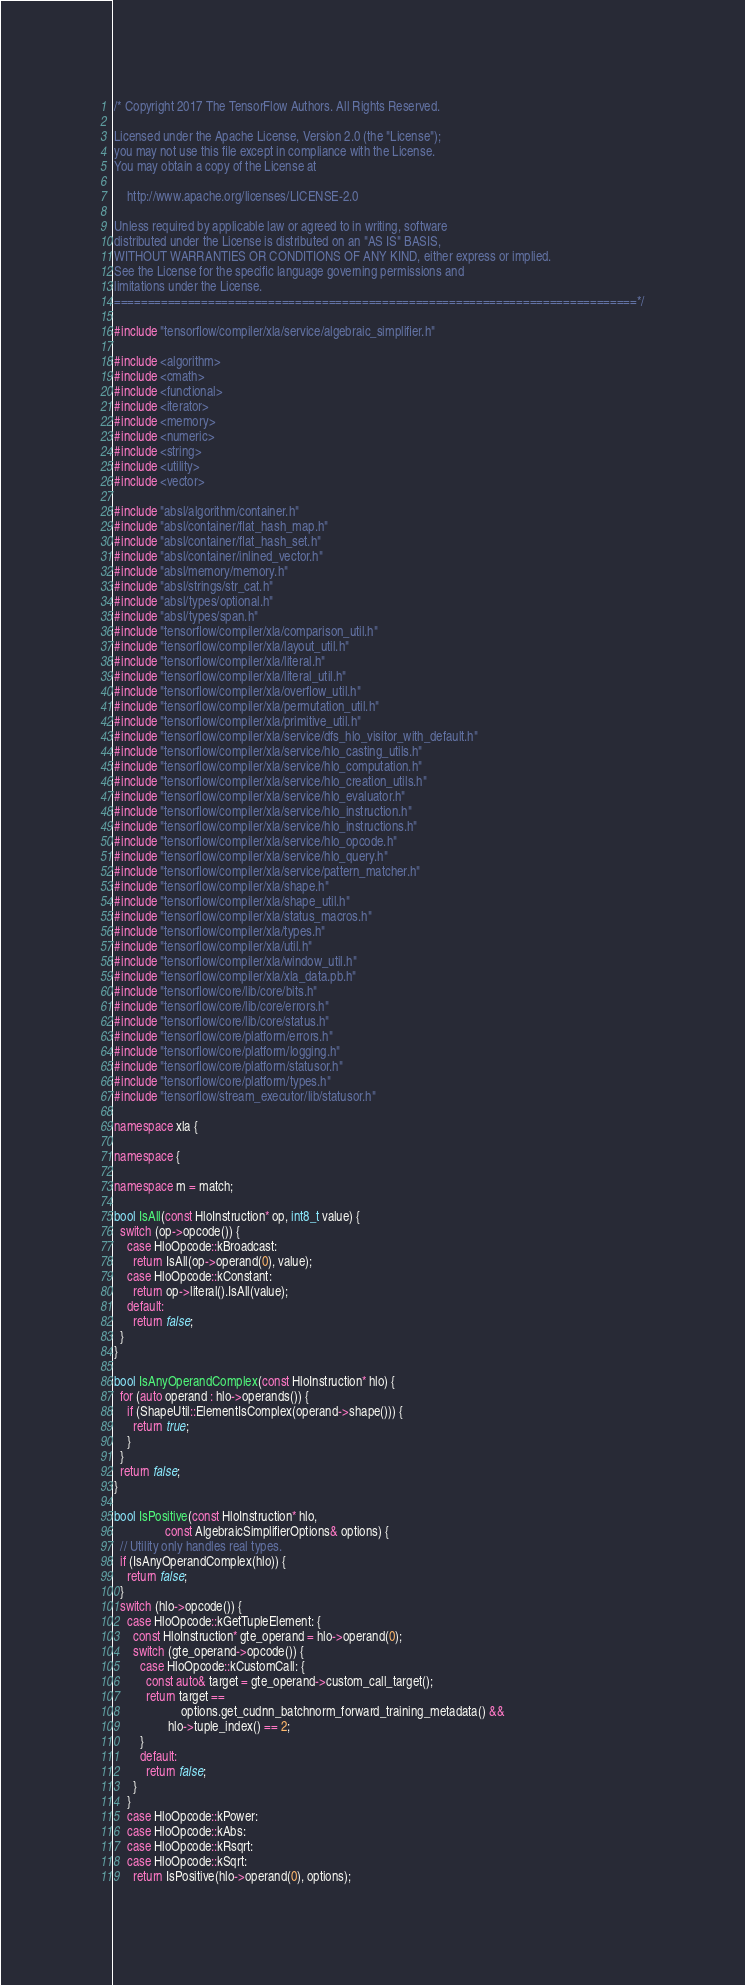Convert code to text. <code><loc_0><loc_0><loc_500><loc_500><_C++_>/* Copyright 2017 The TensorFlow Authors. All Rights Reserved.

Licensed under the Apache License, Version 2.0 (the "License");
you may not use this file except in compliance with the License.
You may obtain a copy of the License at

    http://www.apache.org/licenses/LICENSE-2.0

Unless required by applicable law or agreed to in writing, software
distributed under the License is distributed on an "AS IS" BASIS,
WITHOUT WARRANTIES OR CONDITIONS OF ANY KIND, either express or implied.
See the License for the specific language governing permissions and
limitations under the License.
==============================================================================*/

#include "tensorflow/compiler/xla/service/algebraic_simplifier.h"

#include <algorithm>
#include <cmath>
#include <functional>
#include <iterator>
#include <memory>
#include <numeric>
#include <string>
#include <utility>
#include <vector>

#include "absl/algorithm/container.h"
#include "absl/container/flat_hash_map.h"
#include "absl/container/flat_hash_set.h"
#include "absl/container/inlined_vector.h"
#include "absl/memory/memory.h"
#include "absl/strings/str_cat.h"
#include "absl/types/optional.h"
#include "absl/types/span.h"
#include "tensorflow/compiler/xla/comparison_util.h"
#include "tensorflow/compiler/xla/layout_util.h"
#include "tensorflow/compiler/xla/literal.h"
#include "tensorflow/compiler/xla/literal_util.h"
#include "tensorflow/compiler/xla/overflow_util.h"
#include "tensorflow/compiler/xla/permutation_util.h"
#include "tensorflow/compiler/xla/primitive_util.h"
#include "tensorflow/compiler/xla/service/dfs_hlo_visitor_with_default.h"
#include "tensorflow/compiler/xla/service/hlo_casting_utils.h"
#include "tensorflow/compiler/xla/service/hlo_computation.h"
#include "tensorflow/compiler/xla/service/hlo_creation_utils.h"
#include "tensorflow/compiler/xla/service/hlo_evaluator.h"
#include "tensorflow/compiler/xla/service/hlo_instruction.h"
#include "tensorflow/compiler/xla/service/hlo_instructions.h"
#include "tensorflow/compiler/xla/service/hlo_opcode.h"
#include "tensorflow/compiler/xla/service/hlo_query.h"
#include "tensorflow/compiler/xla/service/pattern_matcher.h"
#include "tensorflow/compiler/xla/shape.h"
#include "tensorflow/compiler/xla/shape_util.h"
#include "tensorflow/compiler/xla/status_macros.h"
#include "tensorflow/compiler/xla/types.h"
#include "tensorflow/compiler/xla/util.h"
#include "tensorflow/compiler/xla/window_util.h"
#include "tensorflow/compiler/xla/xla_data.pb.h"
#include "tensorflow/core/lib/core/bits.h"
#include "tensorflow/core/lib/core/errors.h"
#include "tensorflow/core/lib/core/status.h"
#include "tensorflow/core/platform/errors.h"
#include "tensorflow/core/platform/logging.h"
#include "tensorflow/core/platform/statusor.h"
#include "tensorflow/core/platform/types.h"
#include "tensorflow/stream_executor/lib/statusor.h"

namespace xla {

namespace {

namespace m = match;

bool IsAll(const HloInstruction* op, int8_t value) {
  switch (op->opcode()) {
    case HloOpcode::kBroadcast:
      return IsAll(op->operand(0), value);
    case HloOpcode::kConstant:
      return op->literal().IsAll(value);
    default:
      return false;
  }
}

bool IsAnyOperandComplex(const HloInstruction* hlo) {
  for (auto operand : hlo->operands()) {
    if (ShapeUtil::ElementIsComplex(operand->shape())) {
      return true;
    }
  }
  return false;
}

bool IsPositive(const HloInstruction* hlo,
                const AlgebraicSimplifierOptions& options) {
  // Utility only handles real types.
  if (IsAnyOperandComplex(hlo)) {
    return false;
  }
  switch (hlo->opcode()) {
    case HloOpcode::kGetTupleElement: {
      const HloInstruction* gte_operand = hlo->operand(0);
      switch (gte_operand->opcode()) {
        case HloOpcode::kCustomCall: {
          const auto& target = gte_operand->custom_call_target();
          return target ==
                     options.get_cudnn_batchnorm_forward_training_metadata() &&
                 hlo->tuple_index() == 2;
        }
        default:
          return false;
      }
    }
    case HloOpcode::kPower:
    case HloOpcode::kAbs:
    case HloOpcode::kRsqrt:
    case HloOpcode::kSqrt:
      return IsPositive(hlo->operand(0), options);
</code> 